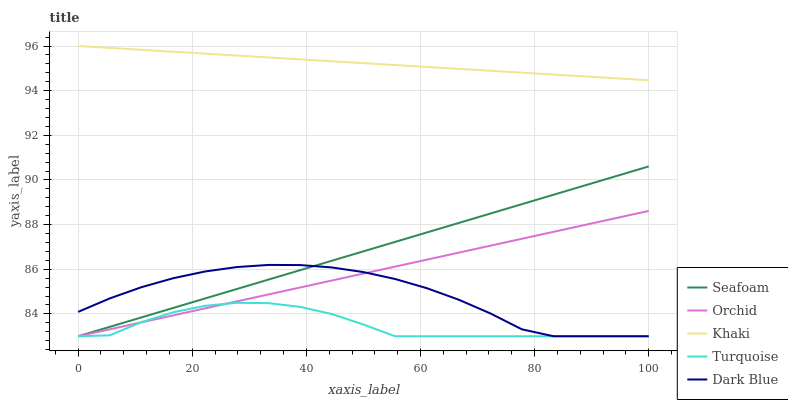Does Khaki have the minimum area under the curve?
Answer yes or no. No. Does Turquoise have the maximum area under the curve?
Answer yes or no. No. Is Khaki the smoothest?
Answer yes or no. No. Is Khaki the roughest?
Answer yes or no. No. Does Khaki have the lowest value?
Answer yes or no. No. Does Turquoise have the highest value?
Answer yes or no. No. Is Turquoise less than Khaki?
Answer yes or no. Yes. Is Khaki greater than Dark Blue?
Answer yes or no. Yes. Does Turquoise intersect Khaki?
Answer yes or no. No. 